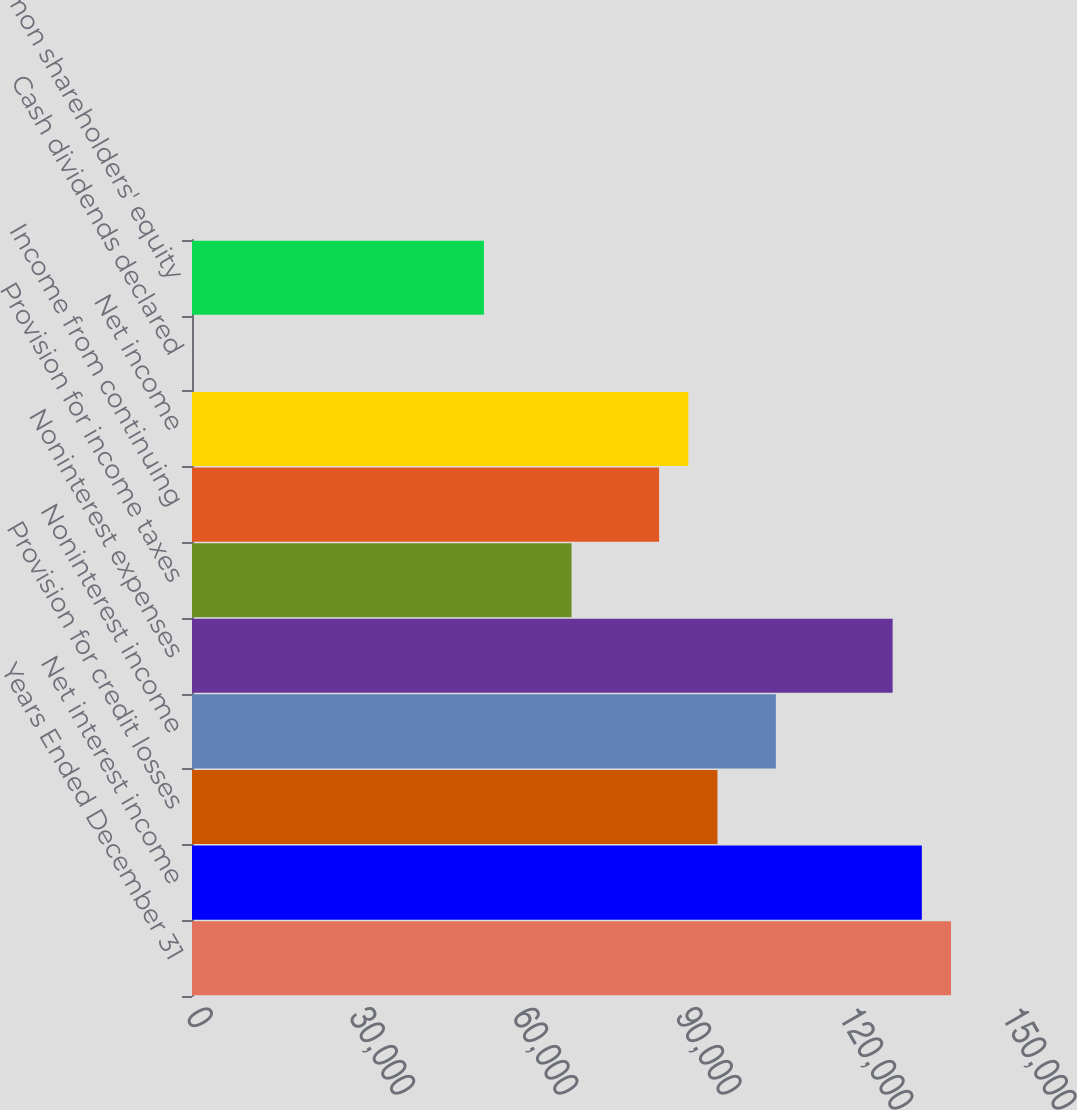Convert chart. <chart><loc_0><loc_0><loc_500><loc_500><bar_chart><fcel>Years Ended December 31<fcel>Net interest income<fcel>Provision for credit losses<fcel>Noninterest income<fcel>Noninterest expenses<fcel>Provision for income taxes<fcel>Income from continuing<fcel>Net income<fcel>Cash dividends declared<fcel>Common shareholders' equity<nl><fcel>139526<fcel>134160<fcel>96595<fcel>107328<fcel>128793<fcel>69763.1<fcel>85862.2<fcel>91228.6<fcel>0.25<fcel>53664<nl></chart> 